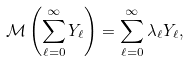<formula> <loc_0><loc_0><loc_500><loc_500>\mathcal { M } \left ( \sum _ { \ell = 0 } ^ { \infty } Y _ { \ell } \right ) = \sum _ { \ell = 0 } ^ { \infty } \lambda _ { \ell } Y _ { \ell } ,</formula> 